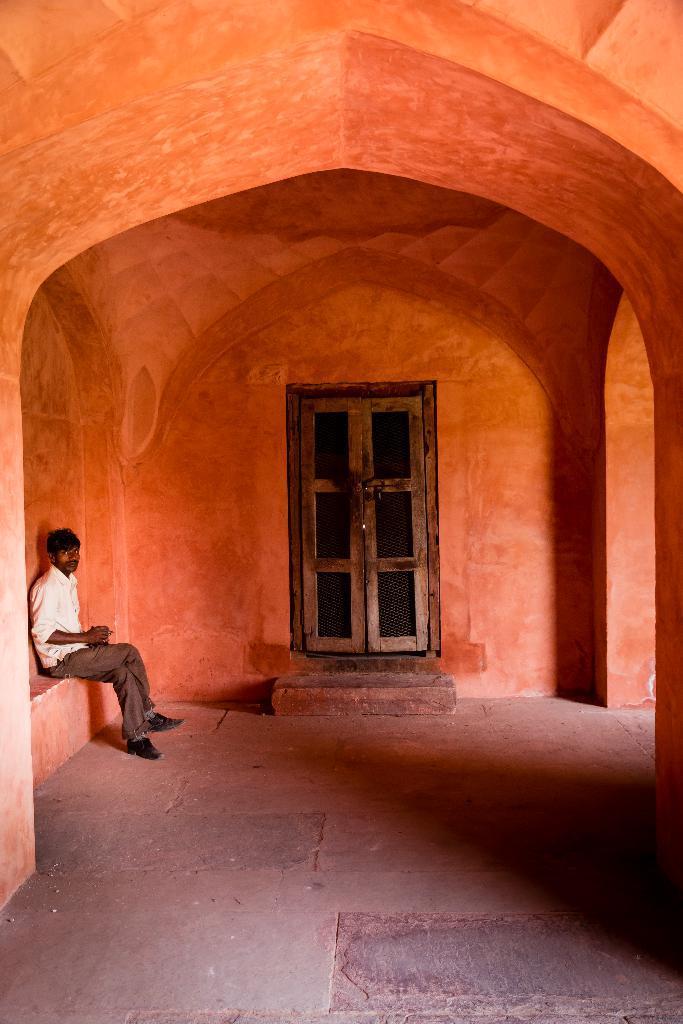Could you give a brief overview of what you see in this image? In this image we can see an arch and pillars. In the back there is a wall with doors. Also we can see a person sitting. 